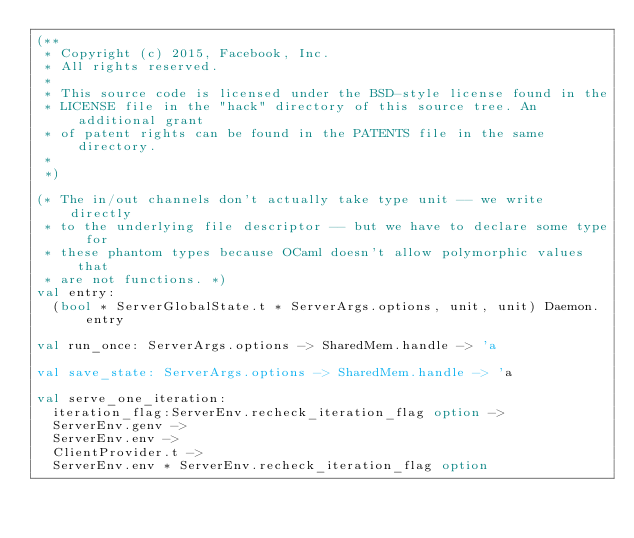<code> <loc_0><loc_0><loc_500><loc_500><_OCaml_>(**
 * Copyright (c) 2015, Facebook, Inc.
 * All rights reserved.
 *
 * This source code is licensed under the BSD-style license found in the
 * LICENSE file in the "hack" directory of this source tree. An additional grant
 * of patent rights can be found in the PATENTS file in the same directory.
 *
 *)

(* The in/out channels don't actually take type unit -- we write directly
 * to the underlying file descriptor -- but we have to declare some type for
 * these phantom types because OCaml doesn't allow polymorphic values that
 * are not functions. *)
val entry:
  (bool * ServerGlobalState.t * ServerArgs.options, unit, unit) Daemon.entry

val run_once: ServerArgs.options -> SharedMem.handle -> 'a

val save_state: ServerArgs.options -> SharedMem.handle -> 'a

val serve_one_iteration:
  iteration_flag:ServerEnv.recheck_iteration_flag option ->
  ServerEnv.genv ->
  ServerEnv.env ->
  ClientProvider.t ->
  ServerEnv.env * ServerEnv.recheck_iteration_flag option
</code> 